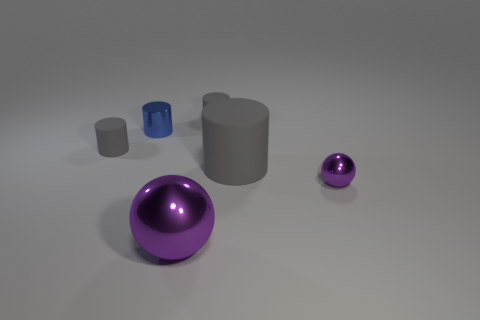Subtract all gray cylinders. How many were subtracted if there are1gray cylinders left? 2 Subtract all gray cubes. How many gray cylinders are left? 3 Subtract all small shiny cylinders. How many cylinders are left? 3 Subtract 2 cylinders. How many cylinders are left? 2 Subtract all blue cylinders. How many cylinders are left? 3 Subtract all blue cylinders. Subtract all green balls. How many cylinders are left? 3 Add 1 large yellow metallic things. How many objects exist? 7 Subtract all cylinders. How many objects are left? 2 Add 2 tiny purple metallic things. How many tiny purple metallic things exist? 3 Subtract 0 green blocks. How many objects are left? 6 